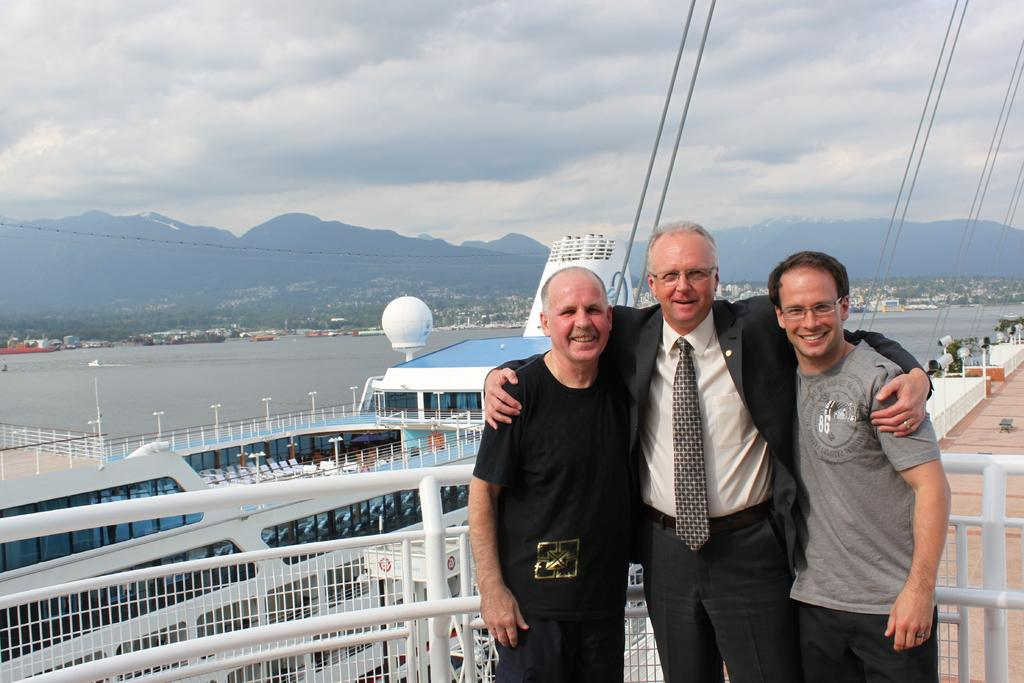How many people are in the image? There are three persons in the image. What are the persons doing in the image? The persons are standing in front of a fence and smiling. What can be seen in the sky in the image? The sky is visible at the top of the image. What other objects or structures are present in the image? Cable wires, a lake, a ship, and a hill are visible in the image. What type of twist can be seen in the image? There is no twist present in the image. How many hooks are visible in the image? There are no hooks visible in the image. 